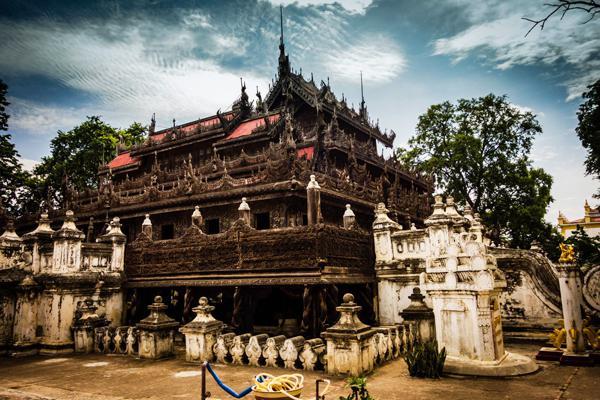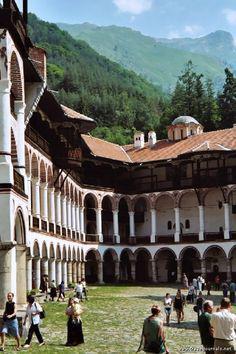The first image is the image on the left, the second image is the image on the right. Examine the images to the left and right. Is the description "One photo shows one or more monks with yellow robes and an umbrella." accurate? Answer yes or no. No. The first image is the image on the left, the second image is the image on the right. For the images displayed, is the sentence "There is at least one person dressed in a yellow robe carrying an umbrella" factually correct? Answer yes or no. No. 